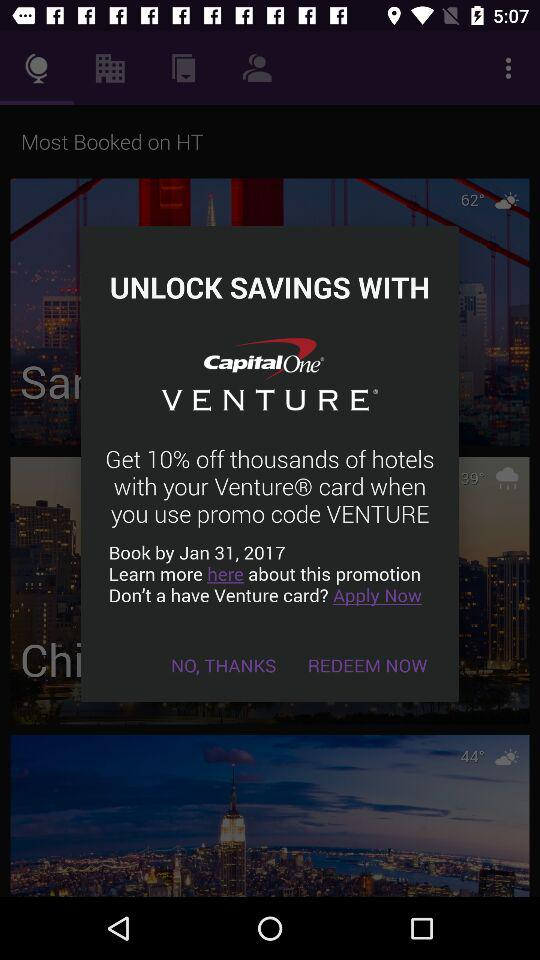What is the booking date? The booking date is January 31, 2017. 